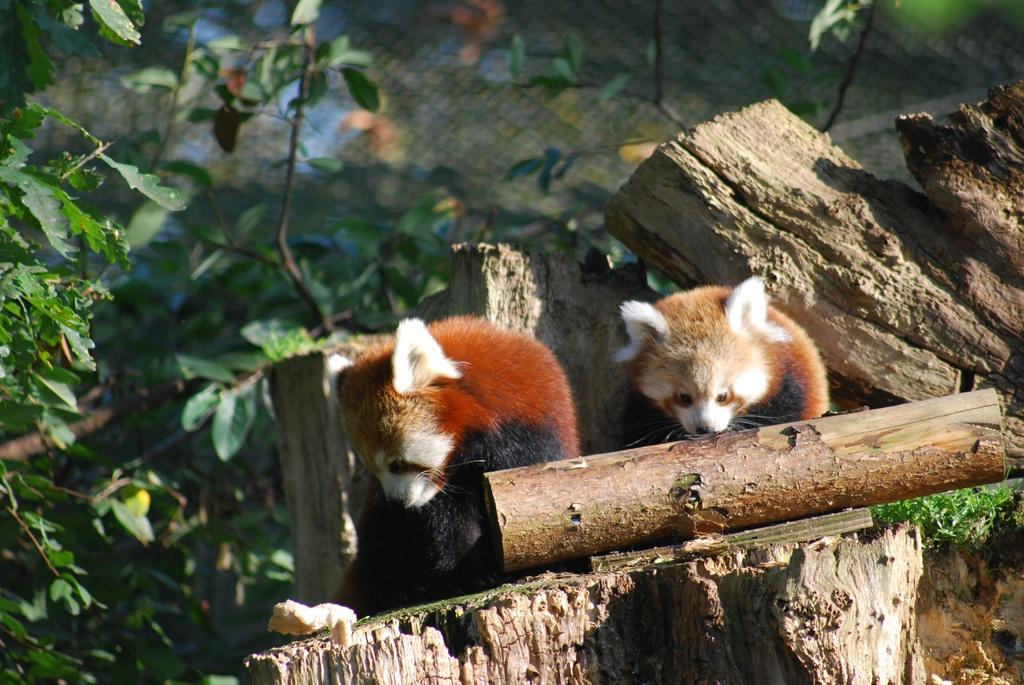What type of animals are in the image? There are red pandas in the image. Where are the red pandas located? The red pandas are on a log. What type of vegetation is visible in the image? There is grass and plants visible in the image. What type of barrier is present in the image? There is a fence in the image. What type of beast is causing trouble with the blade in the image? There is no beast, trouble, or blade mentioned in the image. 